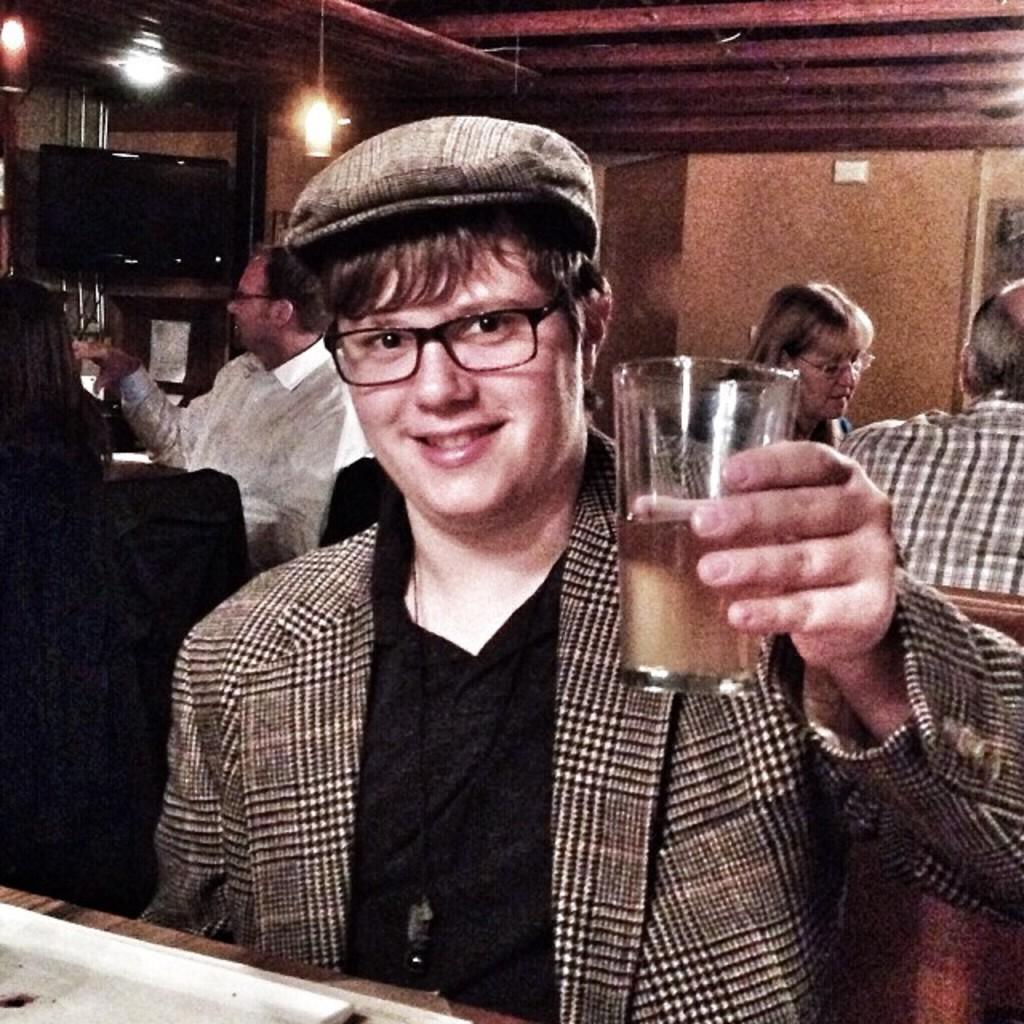In one or two sentences, can you explain what this image depicts? At the top we can see lights. this is a television. We can see persons sitting on chairs. In Front portion of the picture we can see a man holding a glass with drink init in his hand. He wore spectacles and a cap. He is crying a smile on his face. 